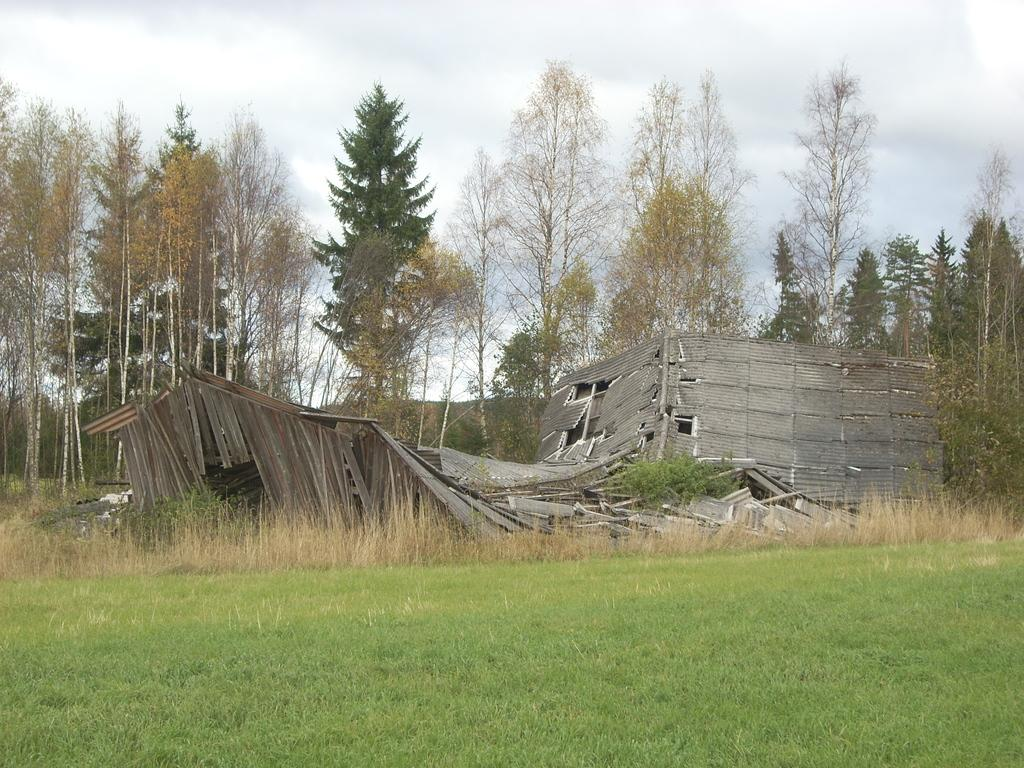What type of surface is visible in the image? There is a grass surface in the image. What structure can be seen on the grass surface? There is a broken wooden house in the image. How far is the wooden house from the grass surface? The wooden house is far from the grass surface. What other natural elements are visible in the image? There are trees visible in the image. What is visible in the background of the image? The sky is visible in the image, and clouds are present in the sky. What type of jail can be seen in the image? There is no jail present in the image. What songs are being sung by the trees in the image? Trees do not sing songs, and there is no indication of any songs being sung in the image. 